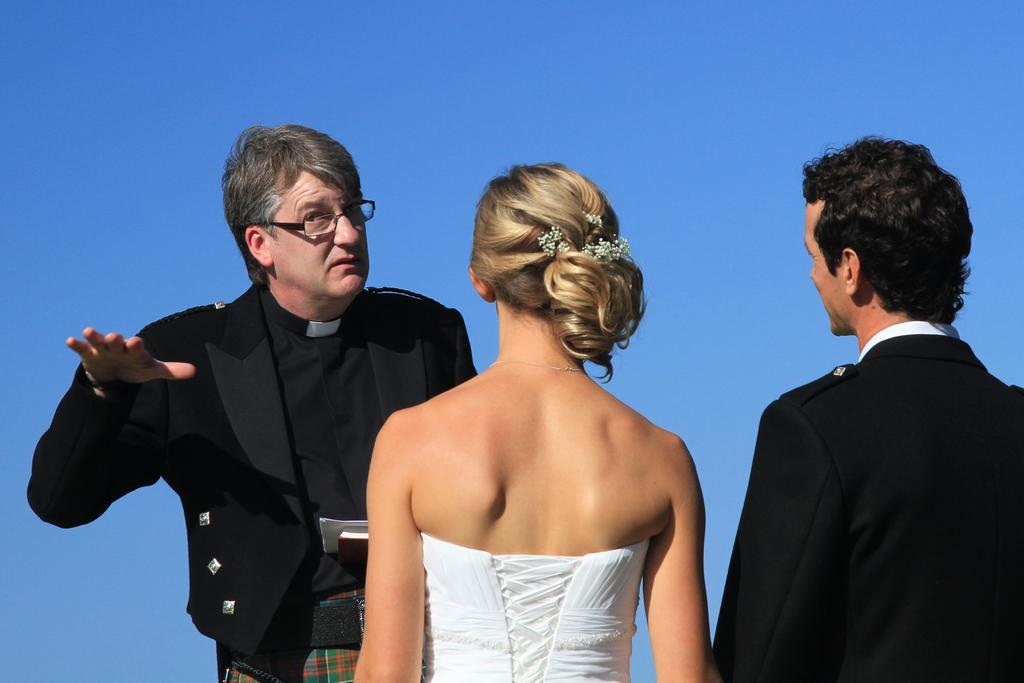How many people are in the image? There are three persons standing in the image. What can be seen in the background of the image? The background of the image is blue. What type of jewel is hanging from the cord in the image? There is no cord or jewel present in the image. How does the sail affect the movement of the persons in the image? There is no sail present in the image, so it cannot affect the movement of the persons. 